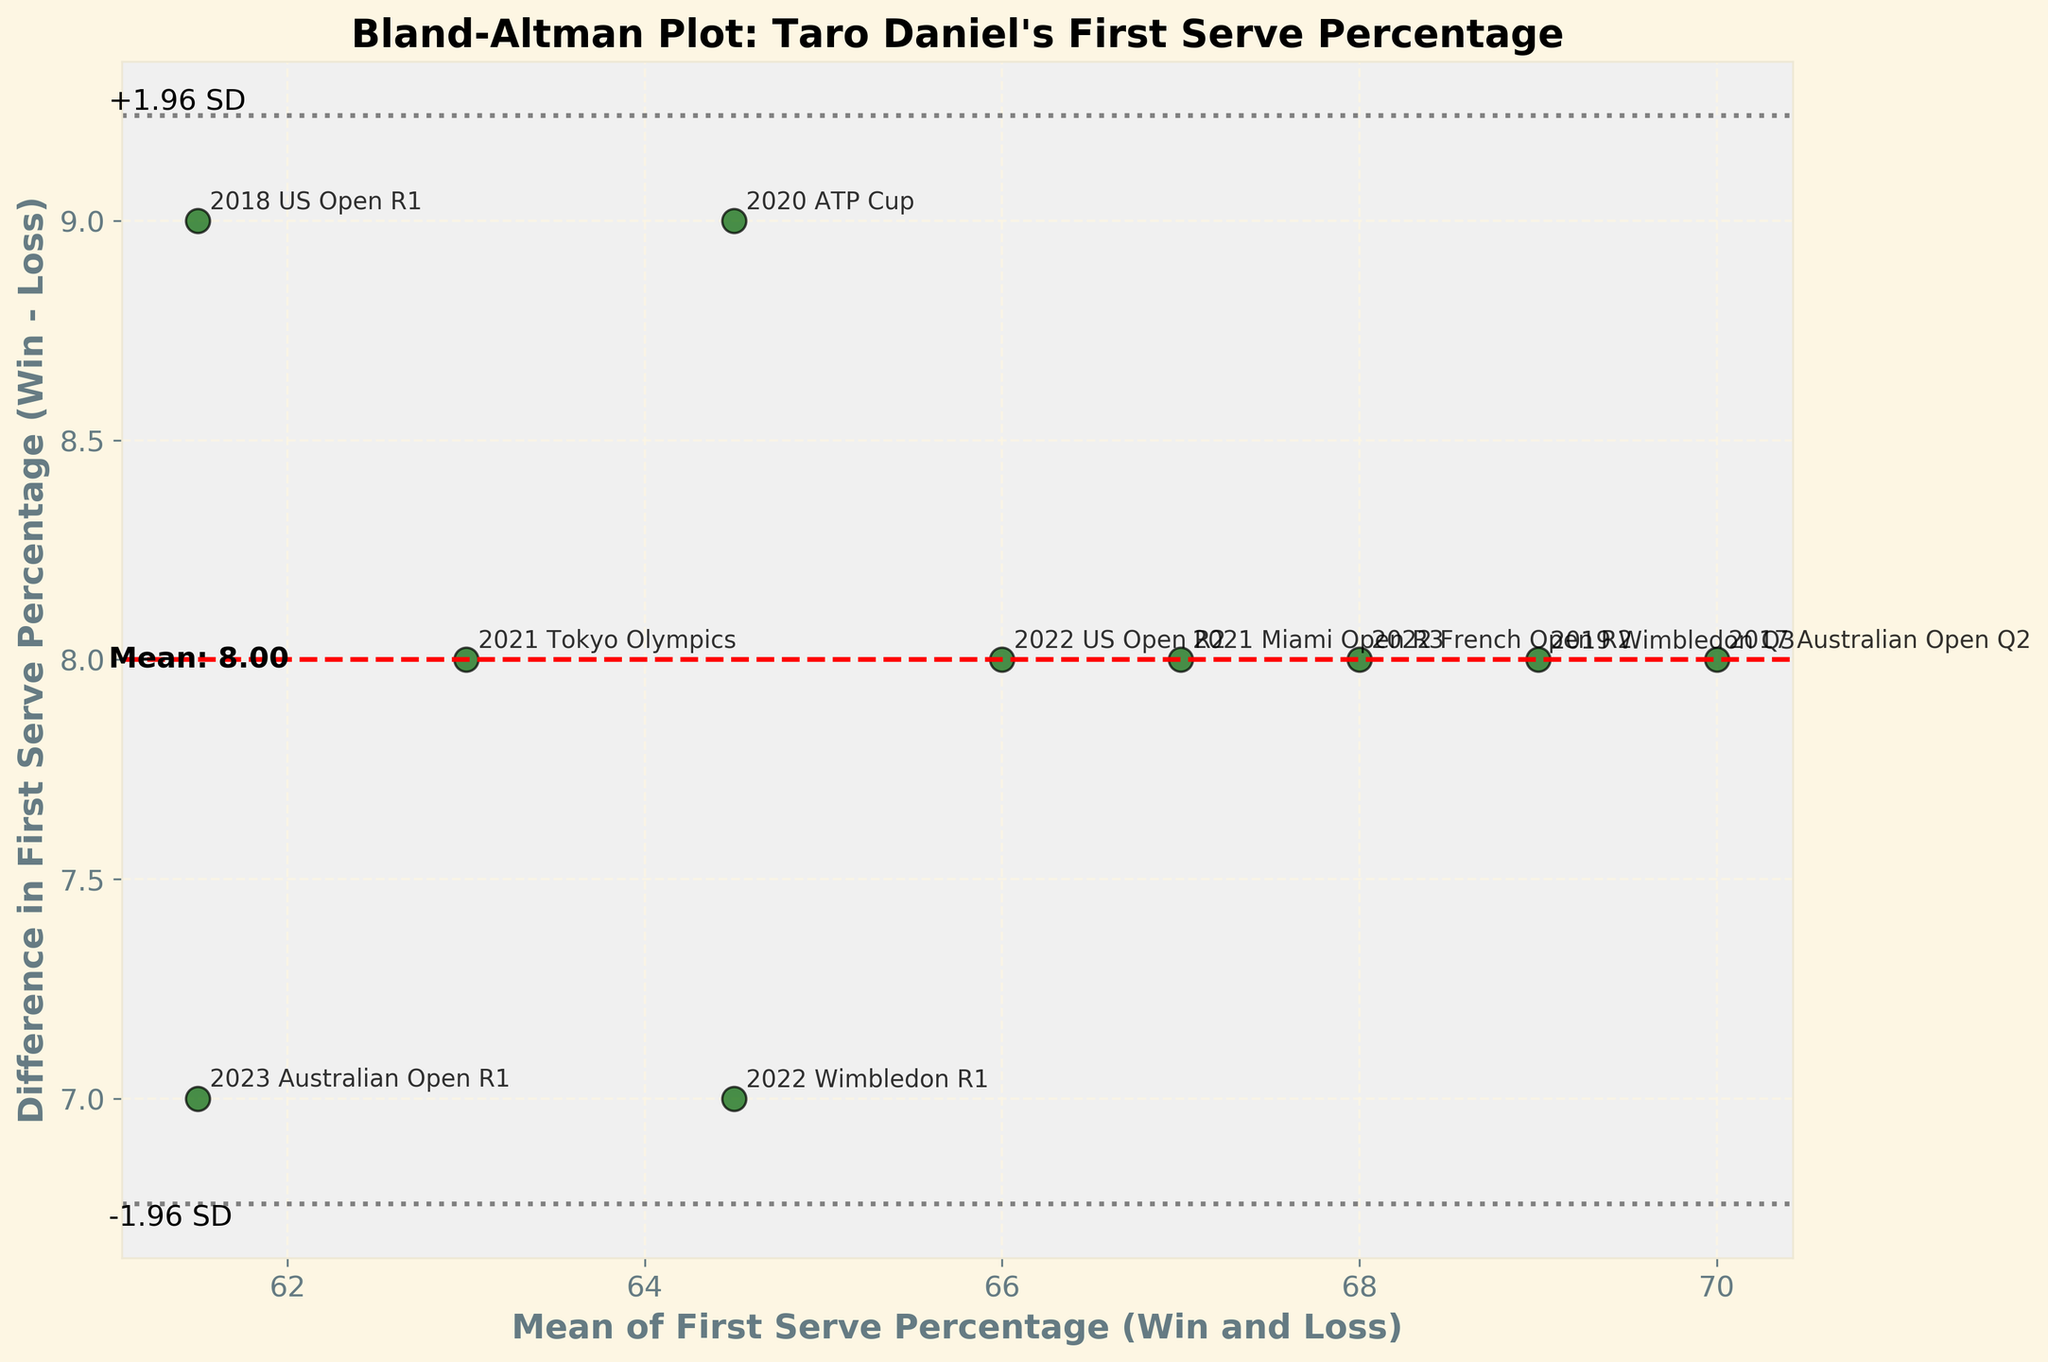What's the title of the plot? The title of the plot is written at the top of the figure. It states what the plot is about.
Answer: Bland-Altman Plot: Taro Daniel's First Serve Percentage How many data points are plotted? To find the number of data points, count the number of scatter plot points on the figure. Each point represents a match.
Answer: 10 What's the average difference in first serve percentages between winning and losing matches? The average difference is represented by the red dashed line. The exact value is annotated on the plot.
Answer: 7 What is the range of the x-axis (Mean of First Serve Percentage)? Look at the x-axis labels to determine the minimum and maximum values that the axis covers.
Answer: 61 to 70 Which match had the highest mean first serve percentage? Identify the highest value on the x-axis and find the corresponding match label.
Answer: 2017 Australian Open Q2 What is the value of the upper limit of agreement (+1.96 SD)? The upper limit of agreement is the line above the mean difference, shown with a “+1.96 SD” annotation.
Answer: 12.42 Which match has the biggest difference between winning and losing first serve percentages? Look at the points on the y-axis to determine which has the highest or lowest difference. The corresponding label shows the match.
Answer: 2017 Australian Open Q2 How are the points distributed overall? Observing the scatter plot, see how the data points are spread around the mean and limits of agreement.
Answer: Mostly centered around mean, some near limits of agreement Which matches have the mean first serve percentage equal to 61.5%? Find the point on the x-axis where the value equals 61.5 and check the corresponding match labels. There could be multiple matches with the same value.
Answer: 2023 Australian Open R1 and 2018 US Open R1 